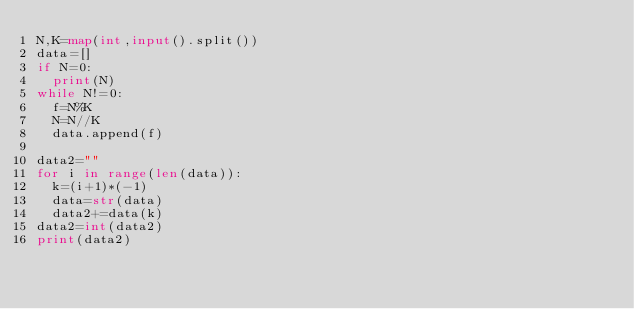<code> <loc_0><loc_0><loc_500><loc_500><_Python_>N,K=map(int,input().split())
data=[]
if N=0:
  print(N)
while N!=0:
  f=N%K
  N=N//K
  data.append(f)
  
data2=""
for i in range(len(data)):
  k=(i+1)*(-1)
  data=str(data)
  data2+=data(k)
data2=int(data2)
print(data2)</code> 